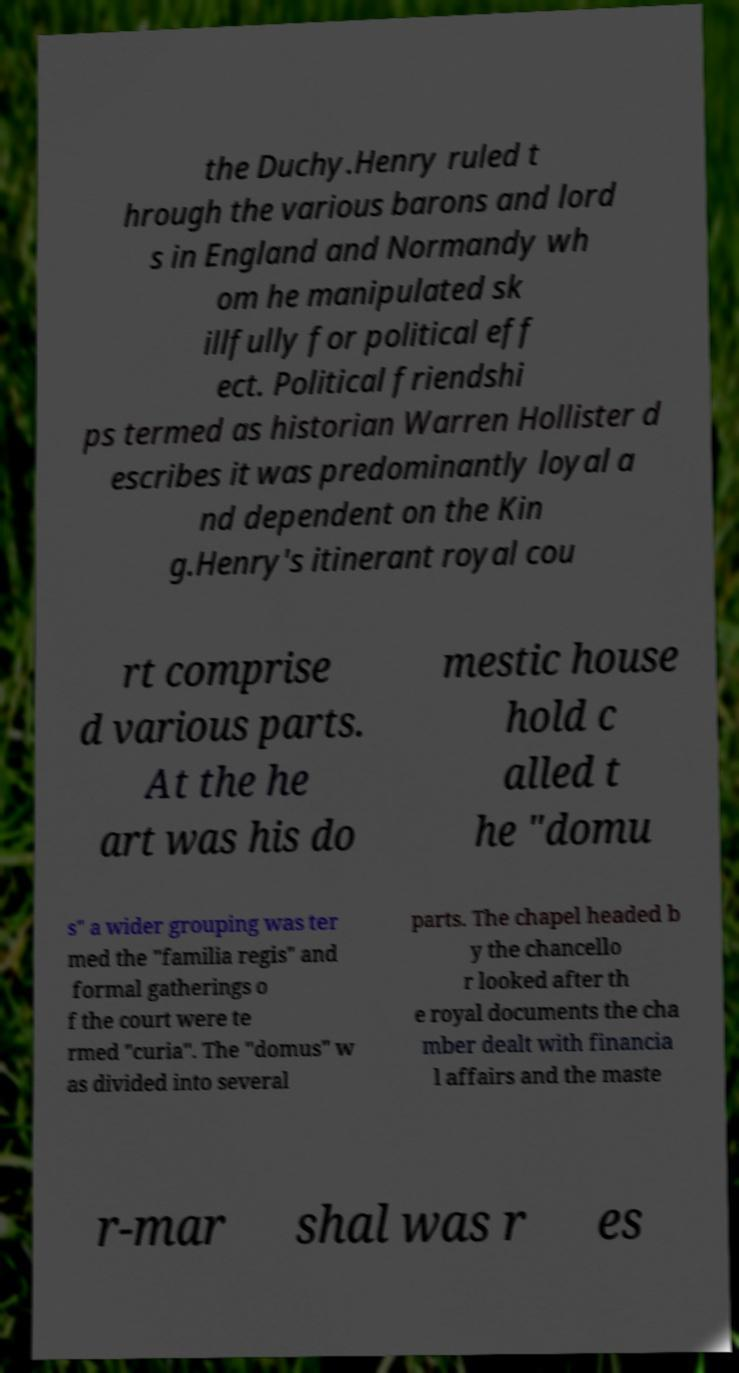There's text embedded in this image that I need extracted. Can you transcribe it verbatim? the Duchy.Henry ruled t hrough the various barons and lord s in England and Normandy wh om he manipulated sk illfully for political eff ect. Political friendshi ps termed as historian Warren Hollister d escribes it was predominantly loyal a nd dependent on the Kin g.Henry's itinerant royal cou rt comprise d various parts. At the he art was his do mestic house hold c alled t he "domu s" a wider grouping was ter med the "familia regis" and formal gatherings o f the court were te rmed "curia". The "domus" w as divided into several parts. The chapel headed b y the chancello r looked after th e royal documents the cha mber dealt with financia l affairs and the maste r-mar shal was r es 